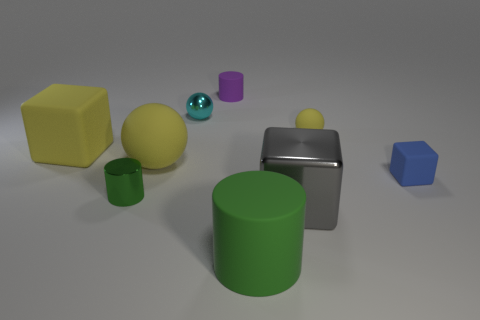Add 1 small yellow rubber objects. How many objects exist? 10 Subtract all small balls. How many balls are left? 1 Subtract all purple cylinders. How many cylinders are left? 2 Subtract all red spheres. How many cyan cylinders are left? 0 Subtract 0 green cubes. How many objects are left? 9 Subtract all cubes. How many objects are left? 6 Subtract 1 balls. How many balls are left? 2 Subtract all blue cylinders. Subtract all cyan spheres. How many cylinders are left? 3 Subtract all metallic cylinders. Subtract all green rubber things. How many objects are left? 7 Add 4 small purple matte cylinders. How many small purple matte cylinders are left? 5 